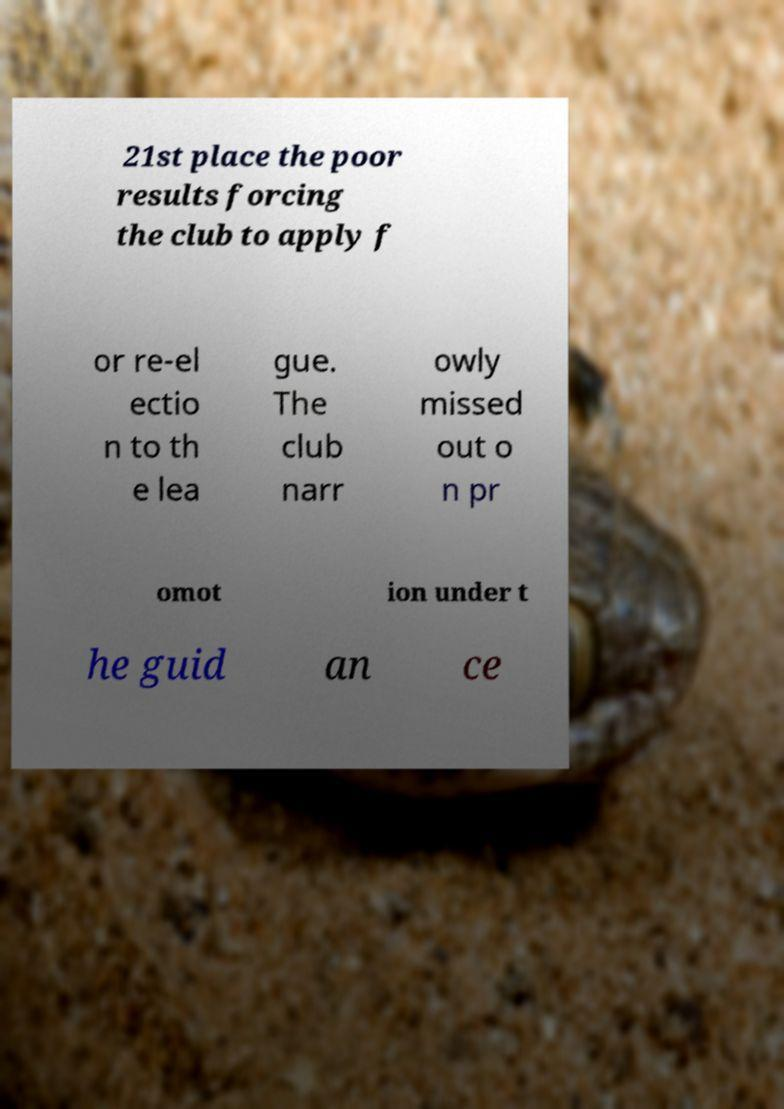Please read and relay the text visible in this image. What does it say? 21st place the poor results forcing the club to apply f or re-el ectio n to th e lea gue. The club narr owly missed out o n pr omot ion under t he guid an ce 